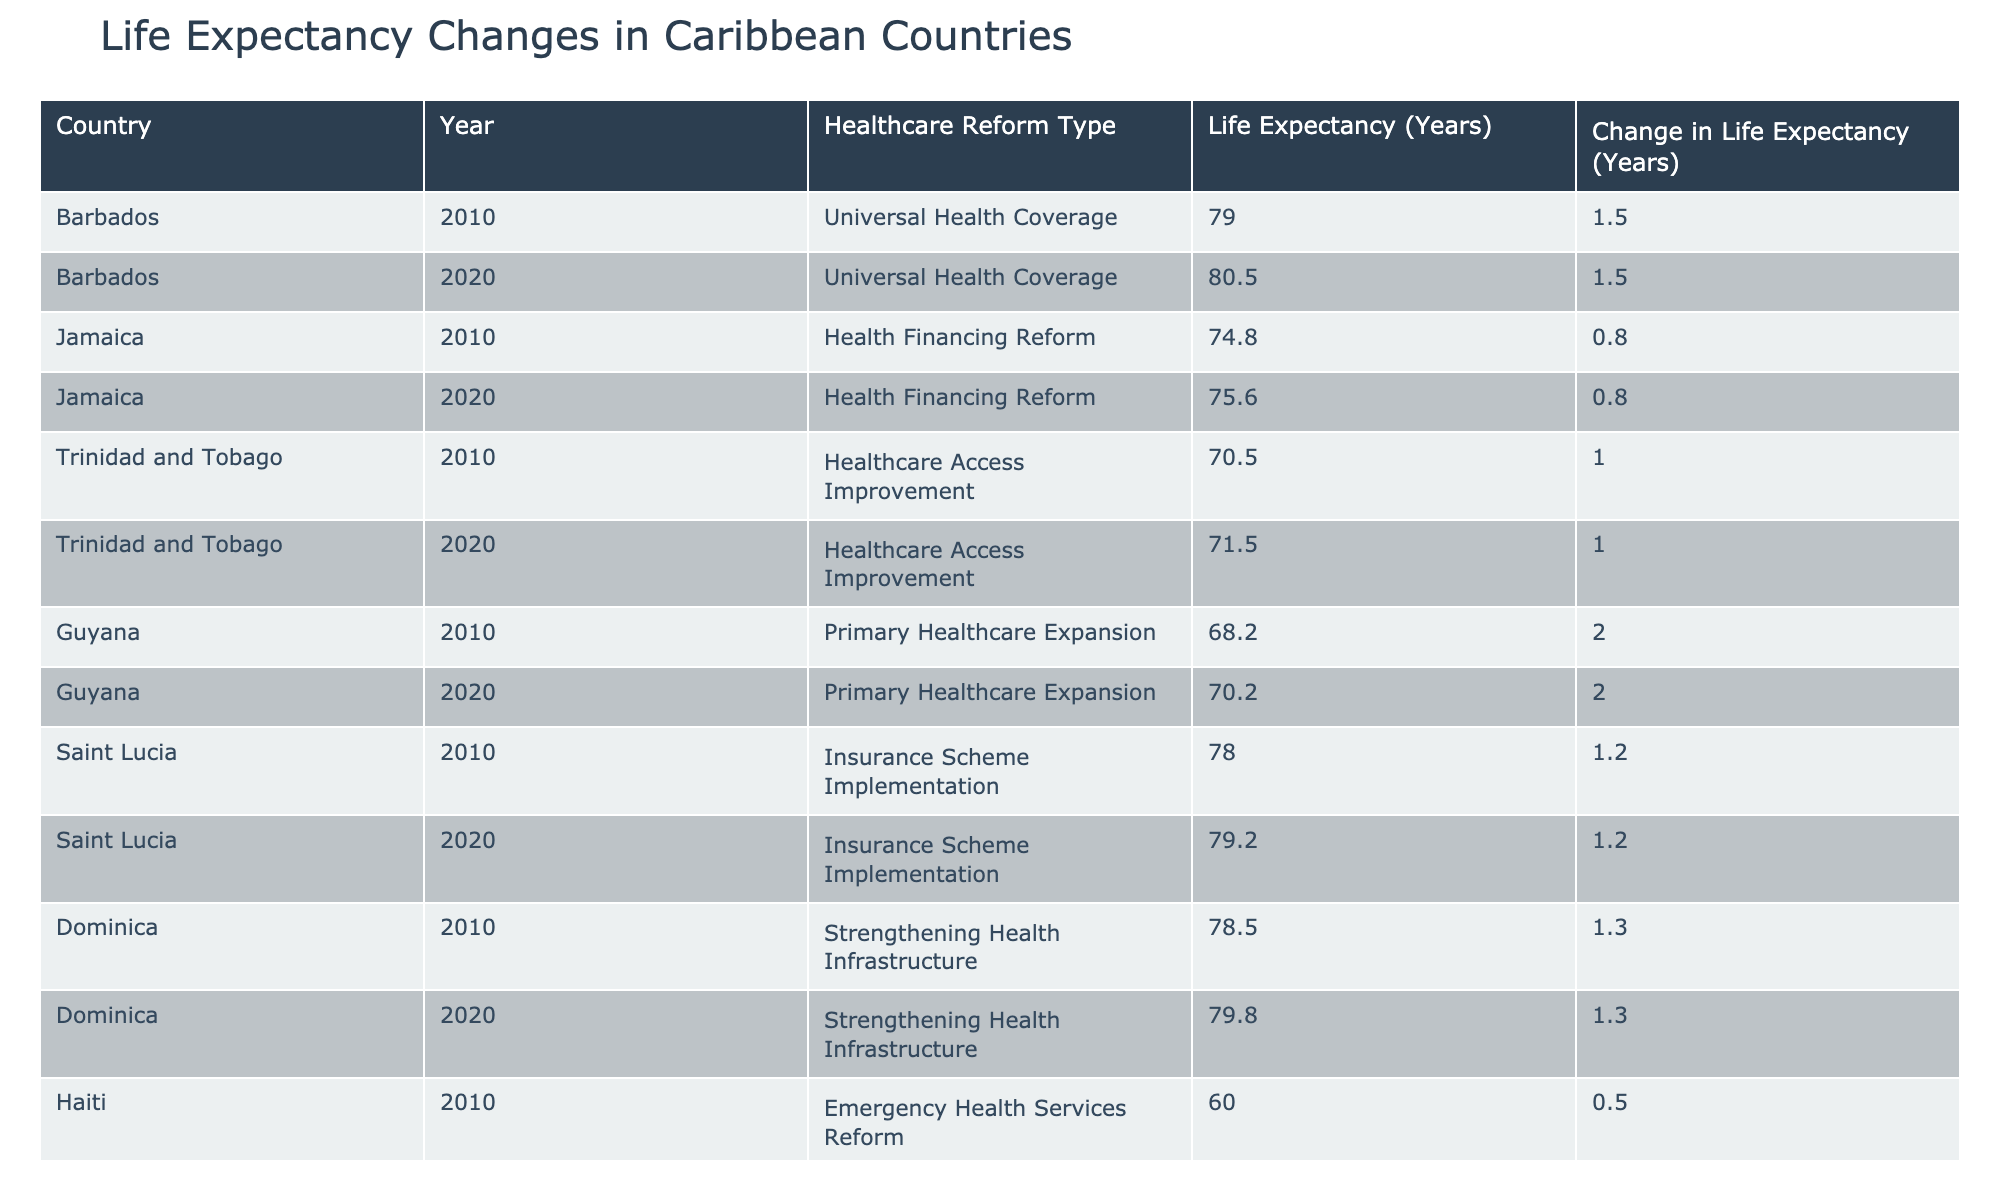What is the life expectancy in Barbados for the year 2020? According to the table, the life expectancy in Barbados for the year 2020 is listed as 80.5 years.
Answer: 80.5 What was the change in life expectancy for Guyana from 2010 to 2020? For Guyana, the life expectancy in 2010 was 68.2 years and in 2020 it was 70.2 years. Subtracting the two gives a change of 70.2 - 68.2 = 2.0 years.
Answer: 2.0 Did Saint Lucia's life expectancy increase from 2010 to 2020? The life expectancy in Saint Lucia was 78.0 years in 2010 and it increased to 79.2 years in 2020, indicating that it did indeed increase.
Answer: Yes Which country had the highest life expectancy in 2020? The life expectancy values in the table for 2020 are: Barbados (80.5), Jamaica (75.6), Trinidad and Tobago (71.5), Guyana (70.2), Saint Lucia (79.2), Dominica (79.8), and Haiti (60.5). Barbados has the highest value at 80.5 years.
Answer: Barbados What was the average life expectancy change across the countries from 2010 to 2020? The changes in life expectancy for each country from 2010 to 2020 are: Barbados (1.5), Jamaica (0.8), Trinidad and Tobago (1.0), Guyana (2.0), Saint Lucia (1.2), Dominica (1.3), and Haiti (0.5). Summing these gives: 1.5 + 0.8 + 1.0 + 2.0 + 1.2 + 1.3 + 0.5 = 8.3. Dividing by the number of countries (7) gives an average of 8.3 / 7 ≈ 1.19.
Answer: 1.19 Have healthcare reforms positively impacted life expectancy across all Caribbean countries listed? The life expectancy changes from 2010 to 2020 show increases for Barbados, Jamaica, Trinidad and Tobago, Guyana, Saint Lucia, Dominica, and only a slight increase for Haiti. Thus, while most have seen positive results, Haiti's minimal change suggests that not all have been significantly impacted.
Answer: No 